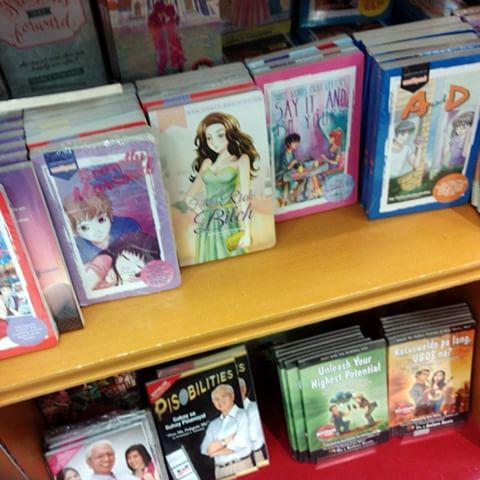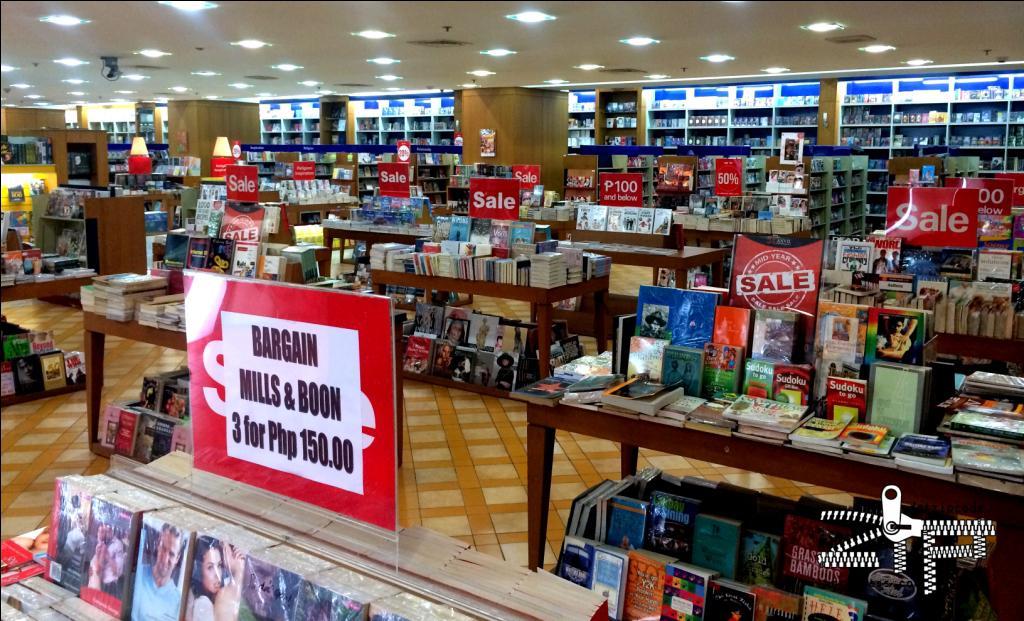The first image is the image on the left, the second image is the image on the right. Considering the images on both sides, is "Left image includes multiple media items with anime characters on the cover and a display featuring bright red and blonde wood." valid? Answer yes or no. Yes. The first image is the image on the left, the second image is the image on the right. Analyze the images presented: Is the assertion "In one of the images there are at least three people shopping in a bookstore." valid? Answer yes or no. No. 